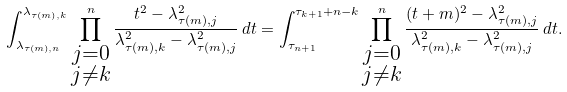<formula> <loc_0><loc_0><loc_500><loc_500>\int _ { \lambda _ { \tau ( m ) , n } } ^ { \lambda _ { \tau ( m ) , k } } \prod _ { \substack { j = 0 \\ j \neq k } } ^ { n } \frac { t ^ { 2 } - \lambda _ { \tau ( m ) , j } ^ { 2 } } { \lambda _ { \tau ( m ) , k } ^ { 2 } - \lambda _ { \tau ( m ) , j } ^ { 2 } } \, d t = \int _ { \tau _ { n + 1 } } ^ { \tau _ { k + 1 } + n - k } \prod _ { \substack { j = 0 \\ j \neq k } } ^ { n } \frac { ( t + m ) ^ { 2 } - \lambda _ { \tau ( m ) , j } ^ { 2 } } { \lambda _ { \tau ( m ) , k } ^ { 2 } - \lambda _ { \tau ( m ) , j } ^ { 2 } } \, d t .</formula> 